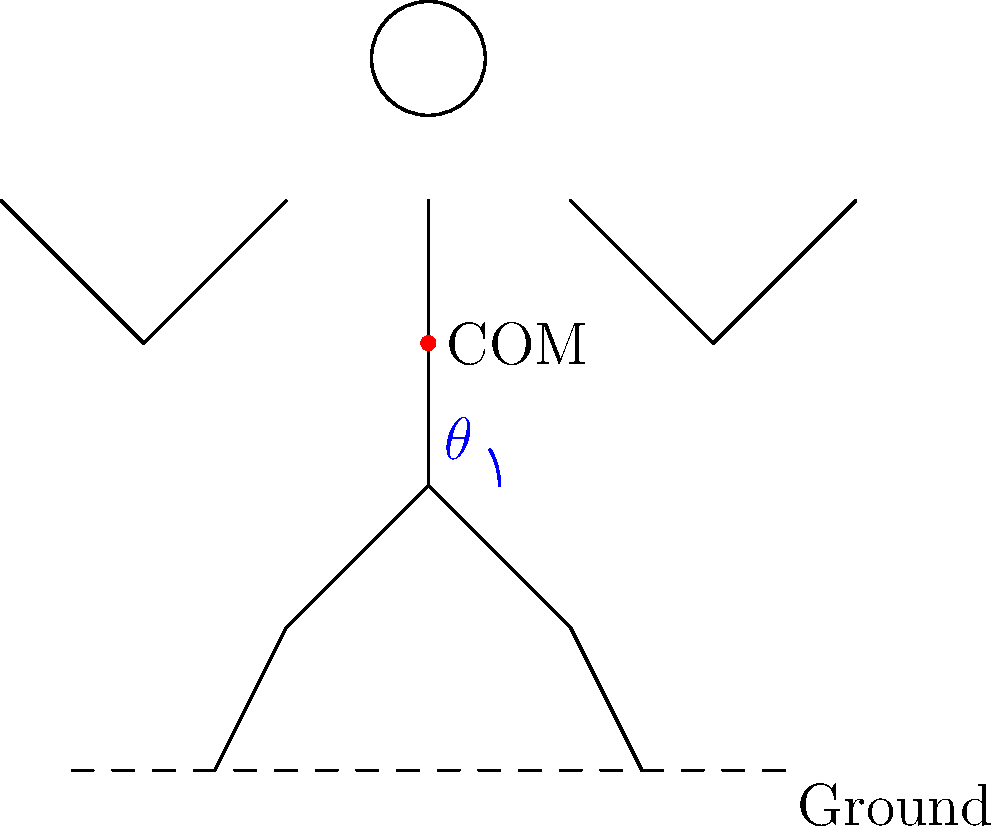In a dramatic Bollywood dance pose, what is the ideal angle $\theta$ between the vertical axis and the line connecting the hip to the center of mass (COM) to maintain balance while maximizing visual impact? To determine the ideal angle for a dramatic Bollywood dance pose, we need to consider both biomechanical stability and aesthetic appeal:

1. Biomechanical stability: The center of mass (COM) should be positioned above the base of support (area between the feet) to maintain balance.

2. Aesthetic appeal: A slight lean or tilt can create a more dynamic and visually striking pose.

3. Bollywood dance style: Often incorporates dramatic, expressive movements that push the limits of balance.

4. Muscle engagement: A small tilt requires core muscle activation, creating a more powerful appearance.

5. Range of motion: The angle should be within a comfortable range for the performer to maintain control.

6. Visual impact: A slight tilt can create lines and shapes that are more interesting to the audience.

Considering these factors, an ideal angle $\theta$ would be approximately 10-15 degrees. This angle:

- Keeps the COM close enough to the center of the base of support for stability
- Creates a noticeable tilt for visual interest
- Is within a comfortable range of motion for most performers
- Requires active muscle engagement, conveying strength and control
- Aligns with the expressive nature of Bollywood dance

This angle allows for a dramatic pose while still maintaining the ability to quickly transition to other movements, which is crucial in dynamic Bollywood choreography.
Answer: 10-15 degrees 